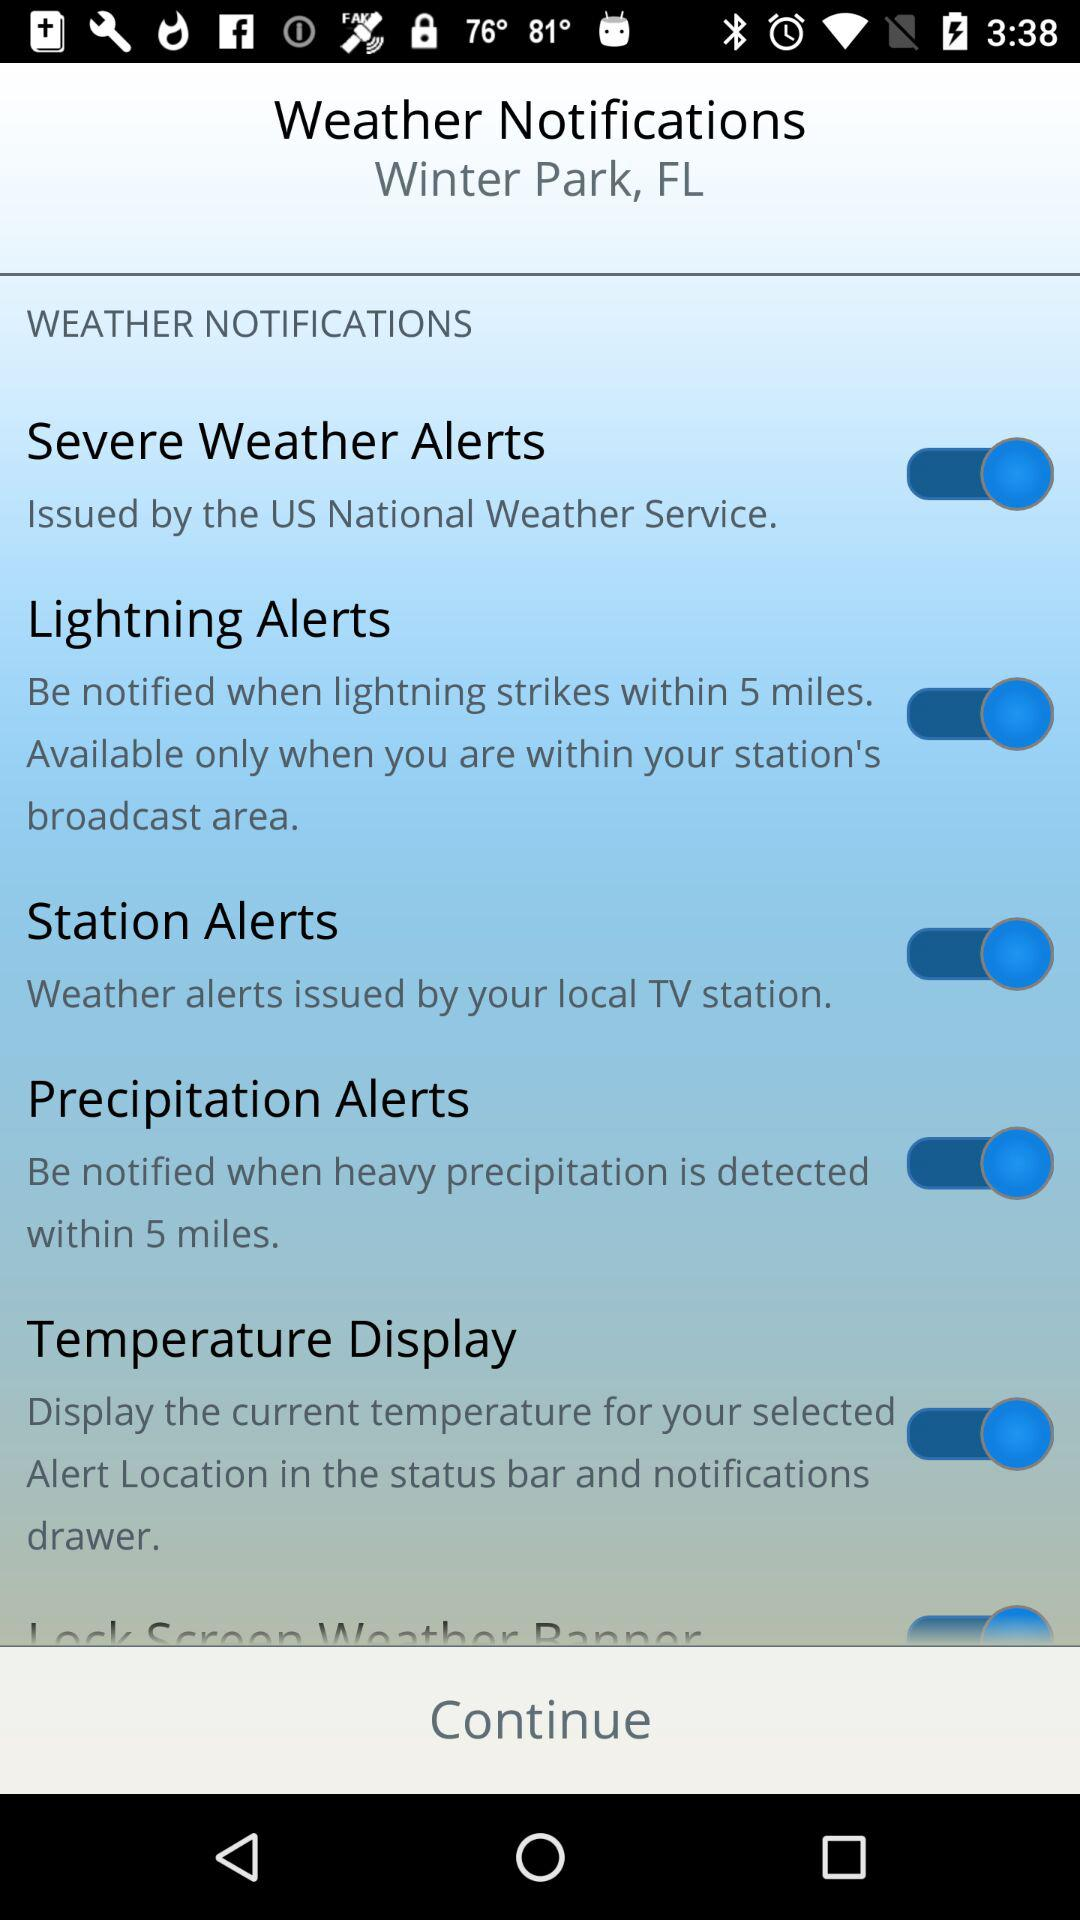What is the status of the "Station Alerts" setting? The status is "on". 